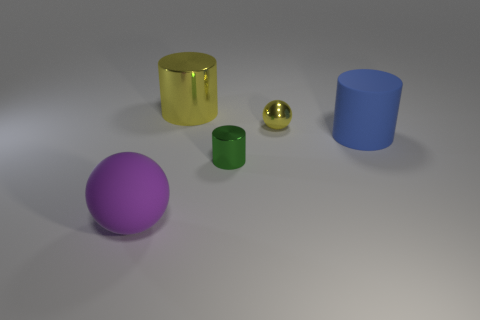Add 1 blue rubber objects. How many objects exist? 6 Subtract all spheres. How many objects are left? 3 Subtract 2 cylinders. How many cylinders are left? 1 Subtract all gray balls. Subtract all brown cubes. How many balls are left? 2 Subtract all cyan cubes. How many purple balls are left? 1 Subtract all tiny cylinders. Subtract all large purple spheres. How many objects are left? 3 Add 1 small shiny balls. How many small shiny balls are left? 2 Add 5 large blue matte things. How many large blue matte things exist? 6 Subtract all yellow balls. How many balls are left? 1 Subtract all large blue cylinders. How many cylinders are left? 2 